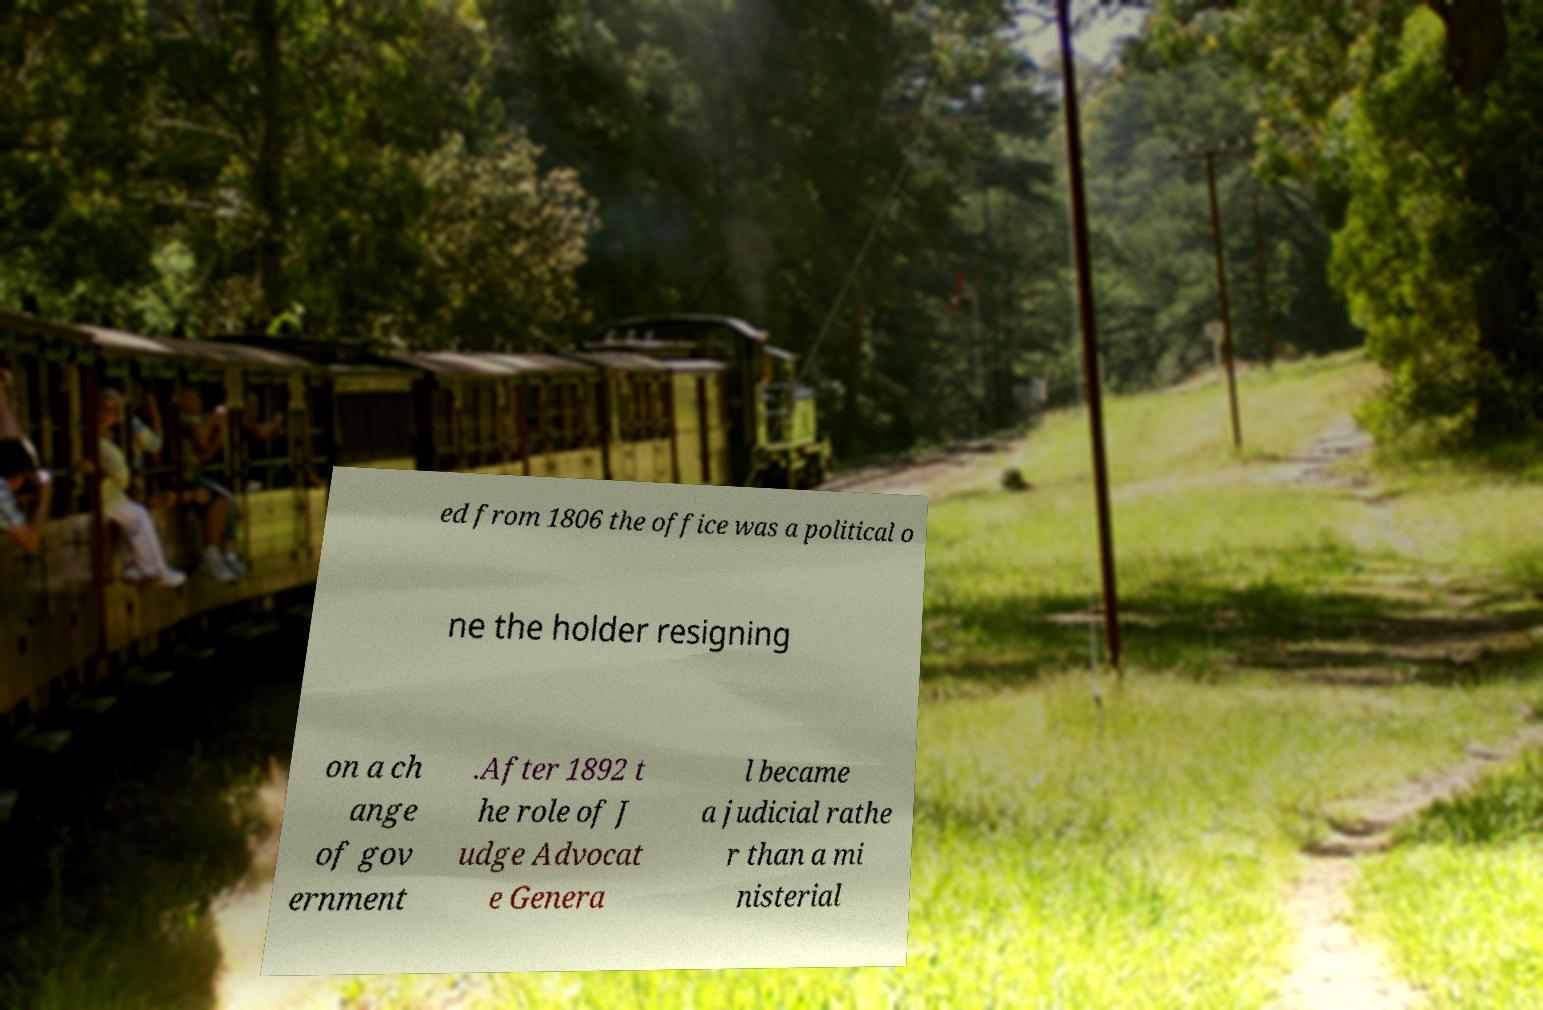I need the written content from this picture converted into text. Can you do that? ed from 1806 the office was a political o ne the holder resigning on a ch ange of gov ernment .After 1892 t he role of J udge Advocat e Genera l became a judicial rathe r than a mi nisterial 